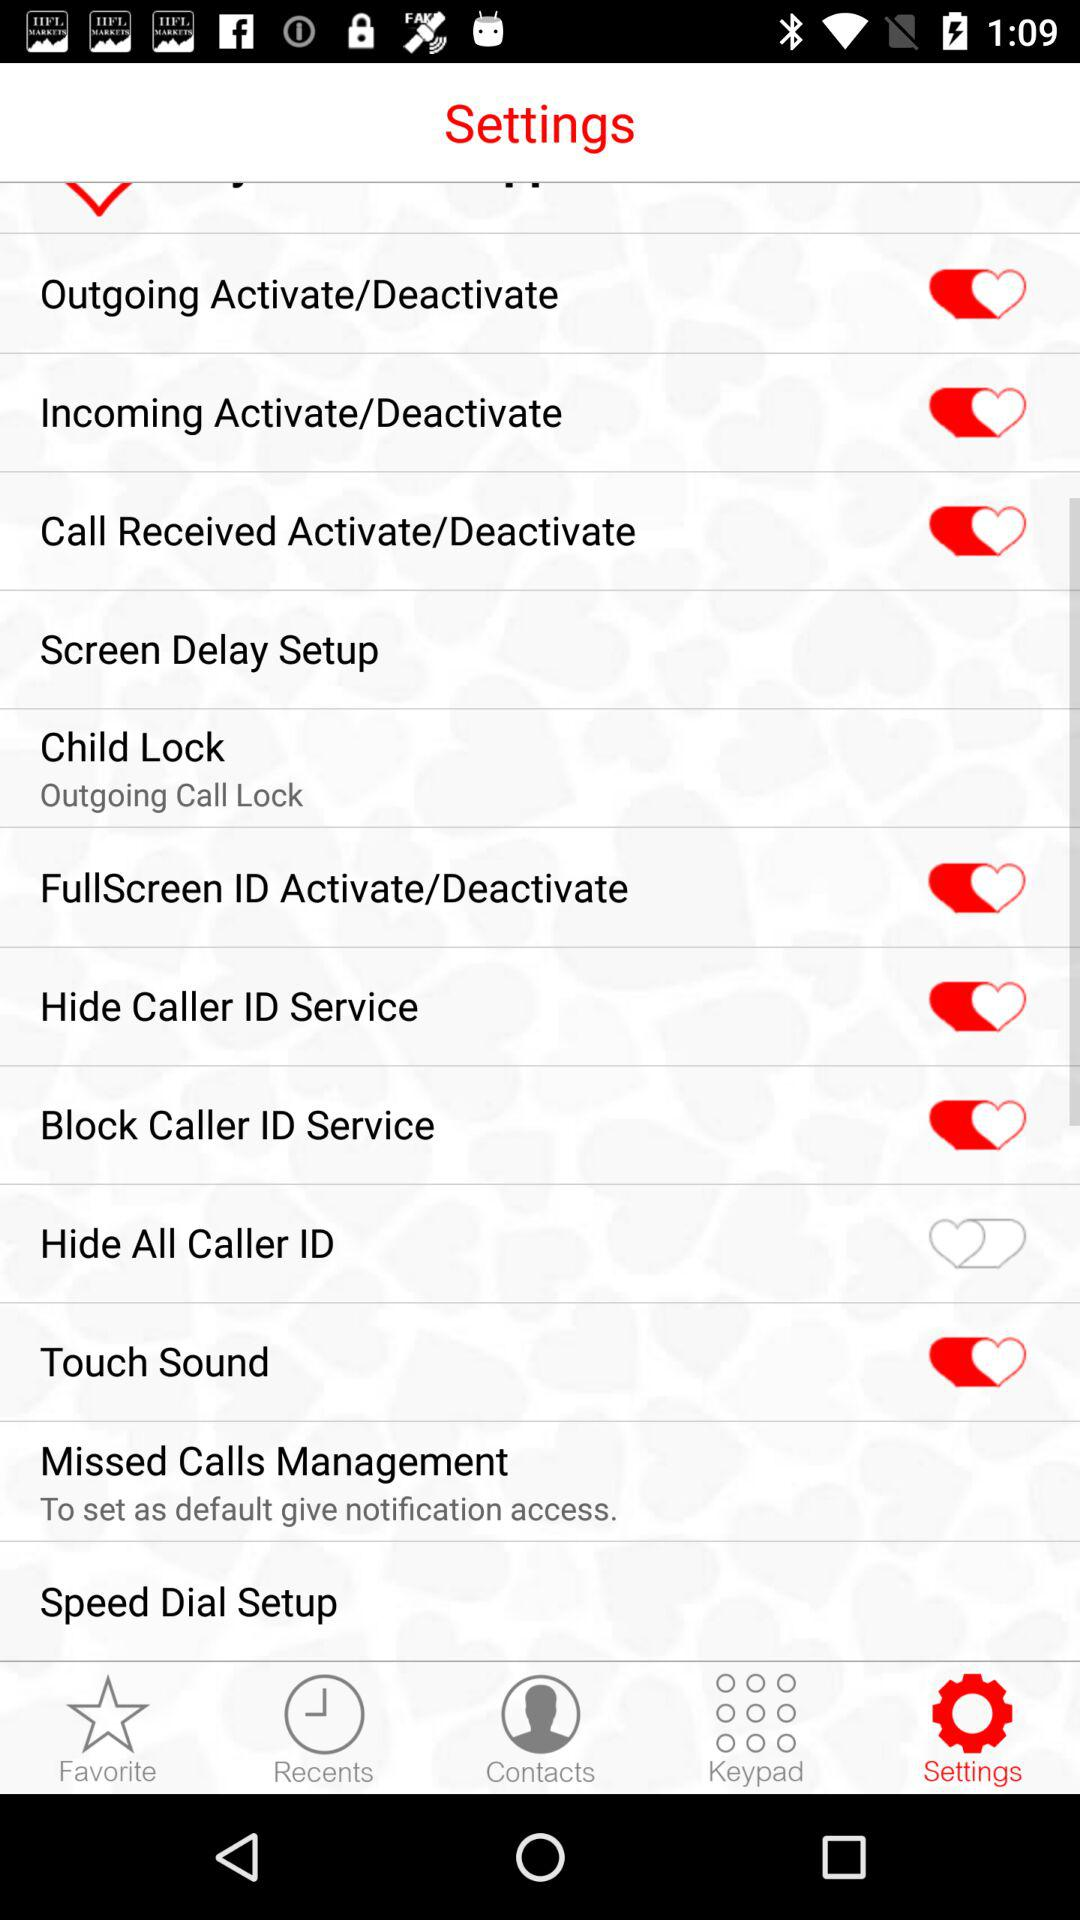What is the selected tab? The selected tab is "Settings". 